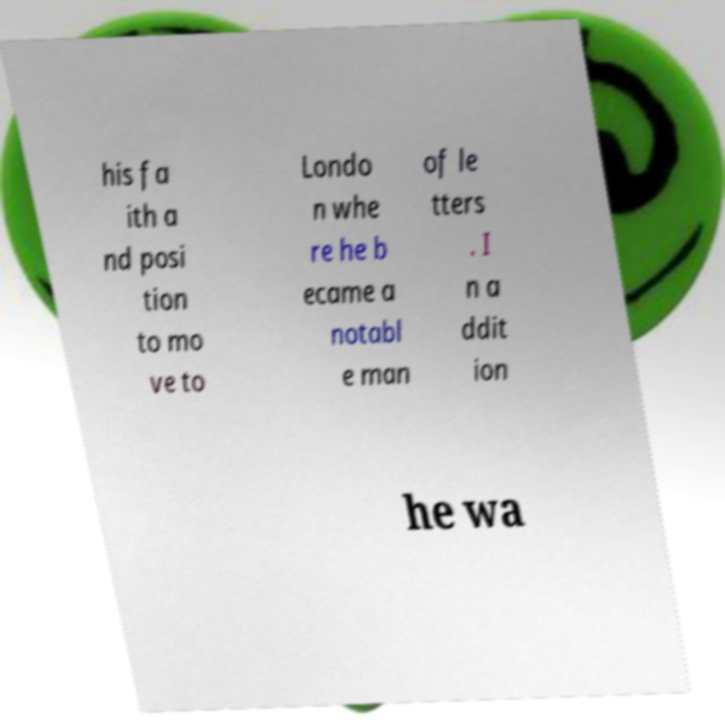Could you extract and type out the text from this image? his fa ith a nd posi tion to mo ve to Londo n whe re he b ecame a notabl e man of le tters . I n a ddit ion he wa 